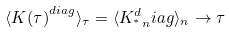Convert formula to latex. <formula><loc_0><loc_0><loc_500><loc_500>\langle { K ( \tau ) } ^ { d i a g } \rangle _ { \tau } = \langle K _ { ^ { * } \, n } ^ { d } i a g \rangle _ { n } \rightarrow \tau</formula> 